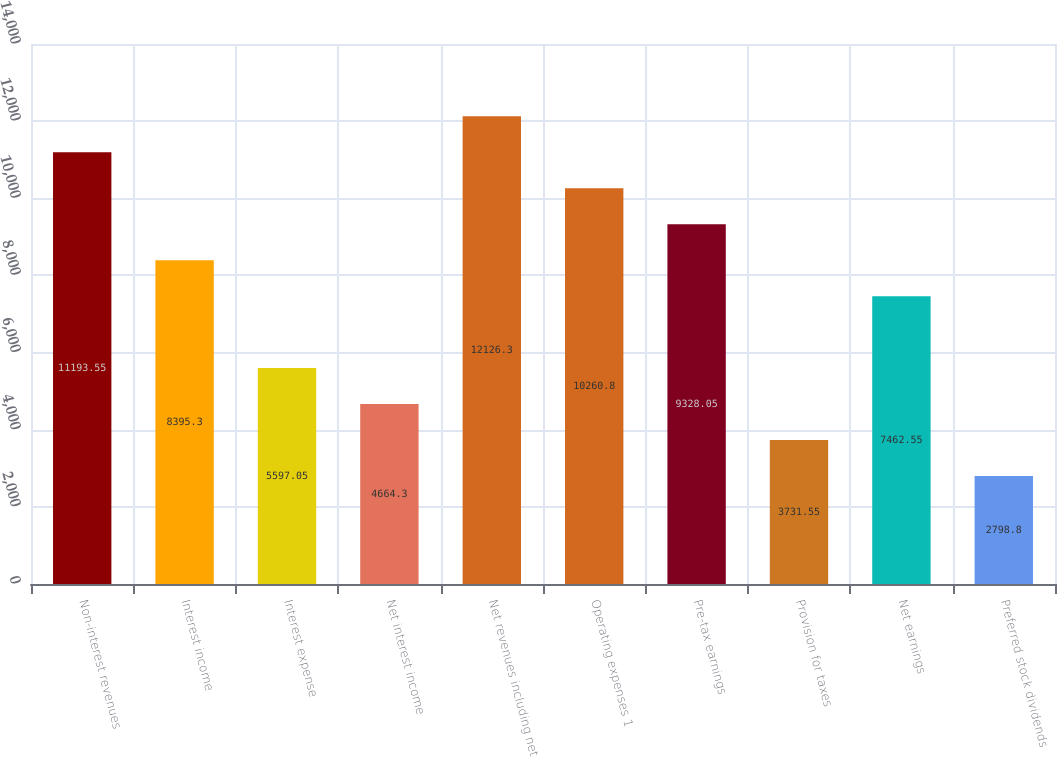Convert chart to OTSL. <chart><loc_0><loc_0><loc_500><loc_500><bar_chart><fcel>Non-interest revenues<fcel>Interest income<fcel>Interest expense<fcel>Net interest income<fcel>Net revenues including net<fcel>Operating expenses 1<fcel>Pre-tax earnings<fcel>Provision for taxes<fcel>Net earnings<fcel>Preferred stock dividends<nl><fcel>11193.5<fcel>8395.3<fcel>5597.05<fcel>4664.3<fcel>12126.3<fcel>10260.8<fcel>9328.05<fcel>3731.55<fcel>7462.55<fcel>2798.8<nl></chart> 